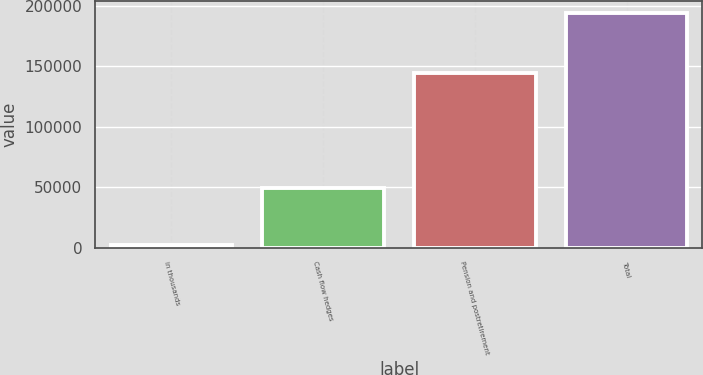<chart> <loc_0><loc_0><loc_500><loc_500><bar_chart><fcel>in thousands<fcel>Cash flow hedges<fcel>Pension and postretirement<fcel>Total<nl><fcel>2009<fcel>49365<fcel>144993<fcel>194358<nl></chart> 